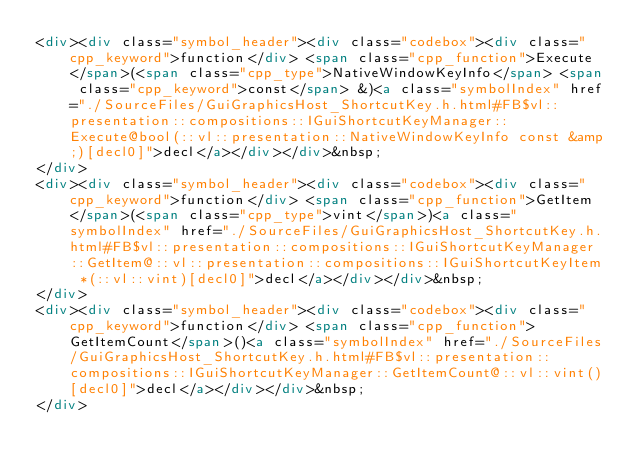Convert code to text. <code><loc_0><loc_0><loc_500><loc_500><_HTML_><div><div class="symbol_header"><div class="codebox"><div class="cpp_keyword">function</div> <span class="cpp_function">Execute</span>(<span class="cpp_type">NativeWindowKeyInfo</span> <span class="cpp_keyword">const</span> &)<a class="symbolIndex" href="./SourceFiles/GuiGraphicsHost_ShortcutKey.h.html#FB$vl::presentation::compositions::IGuiShortcutKeyManager::Execute@bool(::vl::presentation::NativeWindowKeyInfo const &amp;)[decl0]">decl</a></div></div>&nbsp;
</div>
<div><div class="symbol_header"><div class="codebox"><div class="cpp_keyword">function</div> <span class="cpp_function">GetItem</span>(<span class="cpp_type">vint</span>)<a class="symbolIndex" href="./SourceFiles/GuiGraphicsHost_ShortcutKey.h.html#FB$vl::presentation::compositions::IGuiShortcutKeyManager::GetItem@::vl::presentation::compositions::IGuiShortcutKeyItem *(::vl::vint)[decl0]">decl</a></div></div>&nbsp;
</div>
<div><div class="symbol_header"><div class="codebox"><div class="cpp_keyword">function</div> <span class="cpp_function">GetItemCount</span>()<a class="symbolIndex" href="./SourceFiles/GuiGraphicsHost_ShortcutKey.h.html#FB$vl::presentation::compositions::IGuiShortcutKeyManager::GetItemCount@::vl::vint()[decl0]">decl</a></div></div>&nbsp;
</div>
</code> 